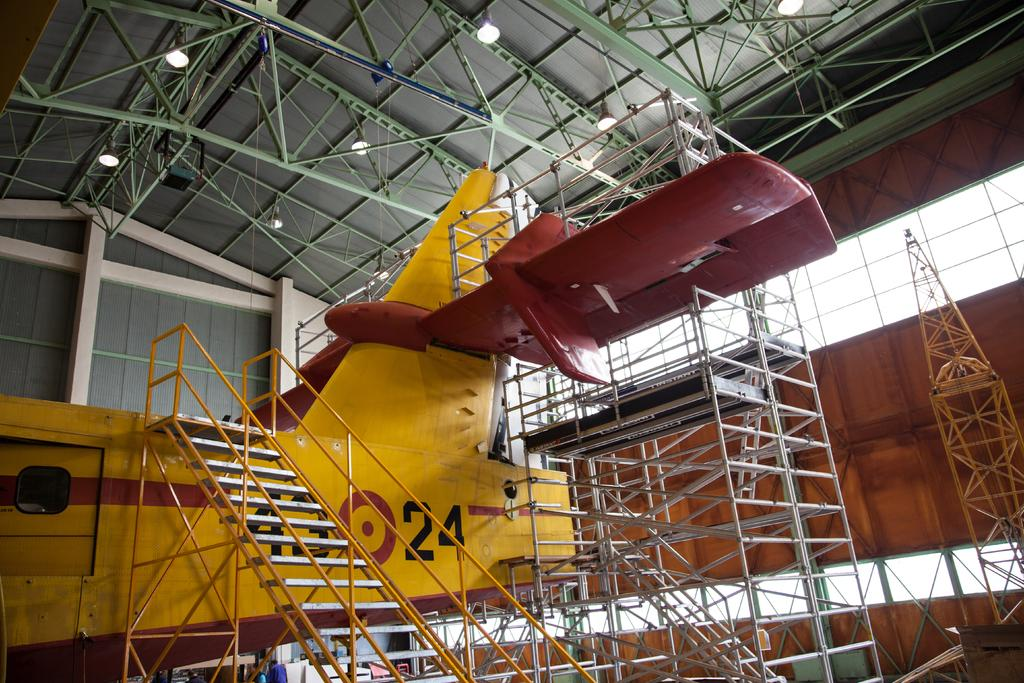<image>
Give a short and clear explanation of the subsequent image. A yellow airplane with number 24 on its side is on a hangar. 